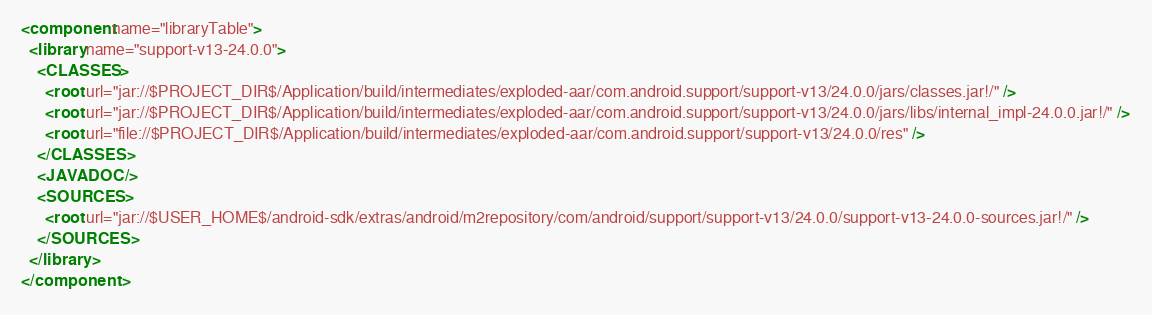<code> <loc_0><loc_0><loc_500><loc_500><_XML_><component name="libraryTable">
  <library name="support-v13-24.0.0">
    <CLASSES>
      <root url="jar://$PROJECT_DIR$/Application/build/intermediates/exploded-aar/com.android.support/support-v13/24.0.0/jars/classes.jar!/" />
      <root url="jar://$PROJECT_DIR$/Application/build/intermediates/exploded-aar/com.android.support/support-v13/24.0.0/jars/libs/internal_impl-24.0.0.jar!/" />
      <root url="file://$PROJECT_DIR$/Application/build/intermediates/exploded-aar/com.android.support/support-v13/24.0.0/res" />
    </CLASSES>
    <JAVADOC />
    <SOURCES>
      <root url="jar://$USER_HOME$/android-sdk/extras/android/m2repository/com/android/support/support-v13/24.0.0/support-v13-24.0.0-sources.jar!/" />
    </SOURCES>
  </library>
</component></code> 